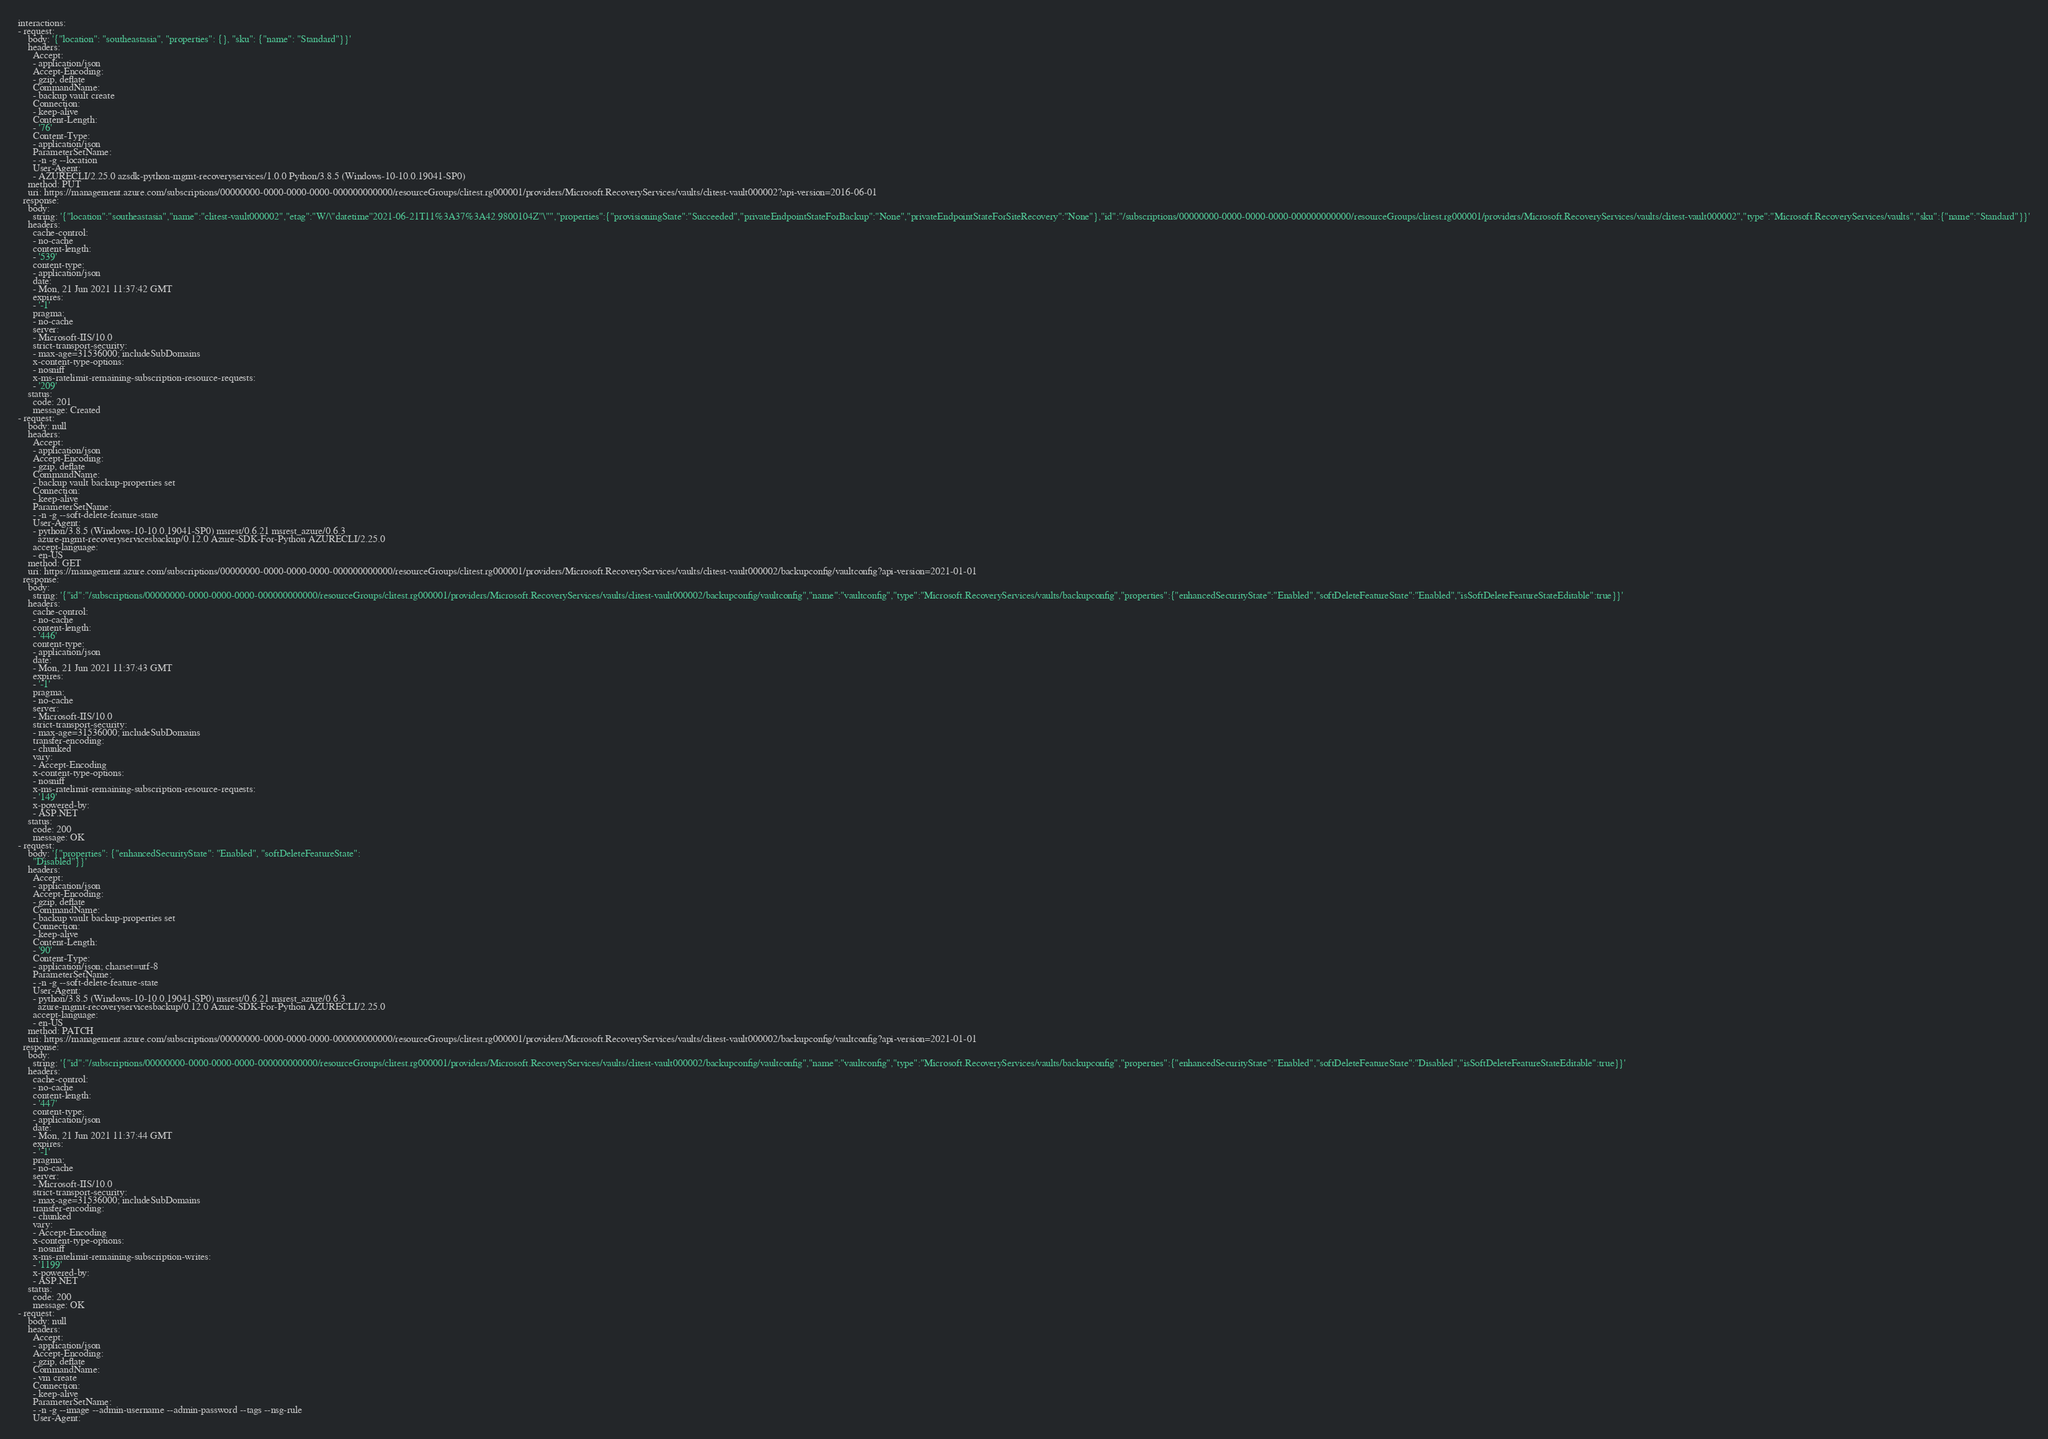Convert code to text. <code><loc_0><loc_0><loc_500><loc_500><_YAML_>interactions:
- request:
    body: '{"location": "southeastasia", "properties": {}, "sku": {"name": "Standard"}}'
    headers:
      Accept:
      - application/json
      Accept-Encoding:
      - gzip, deflate
      CommandName:
      - backup vault create
      Connection:
      - keep-alive
      Content-Length:
      - '76'
      Content-Type:
      - application/json
      ParameterSetName:
      - -n -g --location
      User-Agent:
      - AZURECLI/2.25.0 azsdk-python-mgmt-recoveryservices/1.0.0 Python/3.8.5 (Windows-10-10.0.19041-SP0)
    method: PUT
    uri: https://management.azure.com/subscriptions/00000000-0000-0000-0000-000000000000/resourceGroups/clitest.rg000001/providers/Microsoft.RecoveryServices/vaults/clitest-vault000002?api-version=2016-06-01
  response:
    body:
      string: '{"location":"southeastasia","name":"clitest-vault000002","etag":"W/\"datetime''2021-06-21T11%3A37%3A42.9800104Z''\"","properties":{"provisioningState":"Succeeded","privateEndpointStateForBackup":"None","privateEndpointStateForSiteRecovery":"None"},"id":"/subscriptions/00000000-0000-0000-0000-000000000000/resourceGroups/clitest.rg000001/providers/Microsoft.RecoveryServices/vaults/clitest-vault000002","type":"Microsoft.RecoveryServices/vaults","sku":{"name":"Standard"}}'
    headers:
      cache-control:
      - no-cache
      content-length:
      - '539'
      content-type:
      - application/json
      date:
      - Mon, 21 Jun 2021 11:37:42 GMT
      expires:
      - '-1'
      pragma:
      - no-cache
      server:
      - Microsoft-IIS/10.0
      strict-transport-security:
      - max-age=31536000; includeSubDomains
      x-content-type-options:
      - nosniff
      x-ms-ratelimit-remaining-subscription-resource-requests:
      - '209'
    status:
      code: 201
      message: Created
- request:
    body: null
    headers:
      Accept:
      - application/json
      Accept-Encoding:
      - gzip, deflate
      CommandName:
      - backup vault backup-properties set
      Connection:
      - keep-alive
      ParameterSetName:
      - -n -g --soft-delete-feature-state
      User-Agent:
      - python/3.8.5 (Windows-10-10.0.19041-SP0) msrest/0.6.21 msrest_azure/0.6.3
        azure-mgmt-recoveryservicesbackup/0.12.0 Azure-SDK-For-Python AZURECLI/2.25.0
      accept-language:
      - en-US
    method: GET
    uri: https://management.azure.com/subscriptions/00000000-0000-0000-0000-000000000000/resourceGroups/clitest.rg000001/providers/Microsoft.RecoveryServices/vaults/clitest-vault000002/backupconfig/vaultconfig?api-version=2021-01-01
  response:
    body:
      string: '{"id":"/subscriptions/00000000-0000-0000-0000-000000000000/resourceGroups/clitest.rg000001/providers/Microsoft.RecoveryServices/vaults/clitest-vault000002/backupconfig/vaultconfig","name":"vaultconfig","type":"Microsoft.RecoveryServices/vaults/backupconfig","properties":{"enhancedSecurityState":"Enabled","softDeleteFeatureState":"Enabled","isSoftDeleteFeatureStateEditable":true}}'
    headers:
      cache-control:
      - no-cache
      content-length:
      - '446'
      content-type:
      - application/json
      date:
      - Mon, 21 Jun 2021 11:37:43 GMT
      expires:
      - '-1'
      pragma:
      - no-cache
      server:
      - Microsoft-IIS/10.0
      strict-transport-security:
      - max-age=31536000; includeSubDomains
      transfer-encoding:
      - chunked
      vary:
      - Accept-Encoding
      x-content-type-options:
      - nosniff
      x-ms-ratelimit-remaining-subscription-resource-requests:
      - '149'
      x-powered-by:
      - ASP.NET
    status:
      code: 200
      message: OK
- request:
    body: '{"properties": {"enhancedSecurityState": "Enabled", "softDeleteFeatureState":
      "Disabled"}}'
    headers:
      Accept:
      - application/json
      Accept-Encoding:
      - gzip, deflate
      CommandName:
      - backup vault backup-properties set
      Connection:
      - keep-alive
      Content-Length:
      - '90'
      Content-Type:
      - application/json; charset=utf-8
      ParameterSetName:
      - -n -g --soft-delete-feature-state
      User-Agent:
      - python/3.8.5 (Windows-10-10.0.19041-SP0) msrest/0.6.21 msrest_azure/0.6.3
        azure-mgmt-recoveryservicesbackup/0.12.0 Azure-SDK-For-Python AZURECLI/2.25.0
      accept-language:
      - en-US
    method: PATCH
    uri: https://management.azure.com/subscriptions/00000000-0000-0000-0000-000000000000/resourceGroups/clitest.rg000001/providers/Microsoft.RecoveryServices/vaults/clitest-vault000002/backupconfig/vaultconfig?api-version=2021-01-01
  response:
    body:
      string: '{"id":"/subscriptions/00000000-0000-0000-0000-000000000000/resourceGroups/clitest.rg000001/providers/Microsoft.RecoveryServices/vaults/clitest-vault000002/backupconfig/vaultconfig","name":"vaultconfig","type":"Microsoft.RecoveryServices/vaults/backupconfig","properties":{"enhancedSecurityState":"Enabled","softDeleteFeatureState":"Disabled","isSoftDeleteFeatureStateEditable":true}}'
    headers:
      cache-control:
      - no-cache
      content-length:
      - '447'
      content-type:
      - application/json
      date:
      - Mon, 21 Jun 2021 11:37:44 GMT
      expires:
      - '-1'
      pragma:
      - no-cache
      server:
      - Microsoft-IIS/10.0
      strict-transport-security:
      - max-age=31536000; includeSubDomains
      transfer-encoding:
      - chunked
      vary:
      - Accept-Encoding
      x-content-type-options:
      - nosniff
      x-ms-ratelimit-remaining-subscription-writes:
      - '1199'
      x-powered-by:
      - ASP.NET
    status:
      code: 200
      message: OK
- request:
    body: null
    headers:
      Accept:
      - application/json
      Accept-Encoding:
      - gzip, deflate
      CommandName:
      - vm create
      Connection:
      - keep-alive
      ParameterSetName:
      - -n -g --image --admin-username --admin-password --tags --nsg-rule
      User-Agent:</code> 